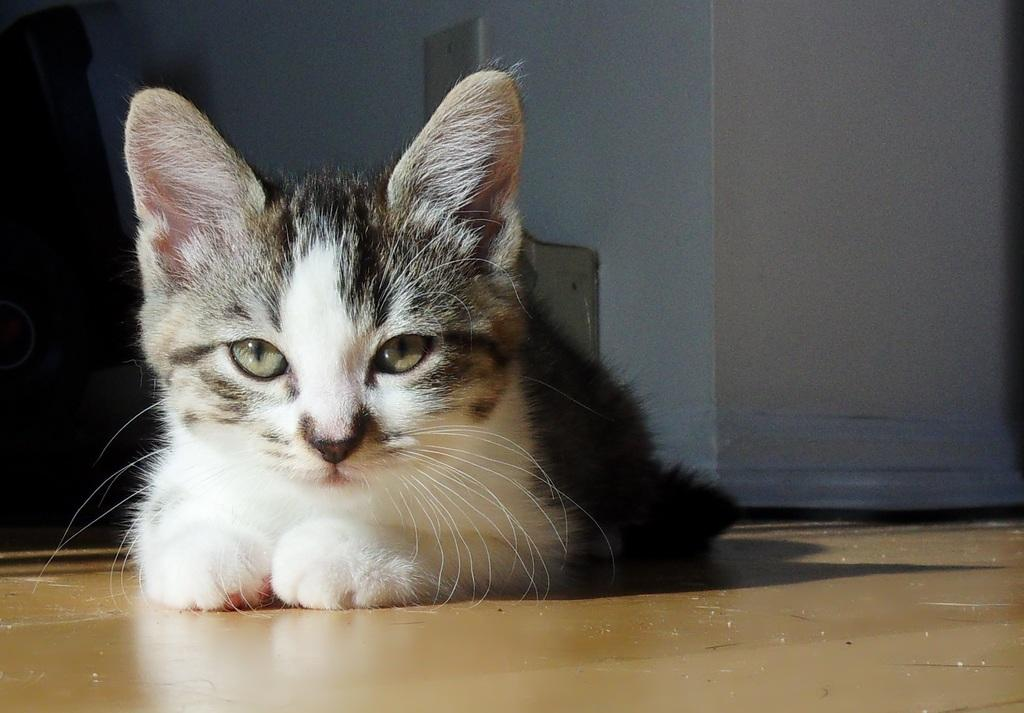Where was the image taken? The image was taken inside a room. What is in the foreground of the image? There is a cat in the foreground of the image. What is the cat doing in the image? The cat is sitting on the floor. What can be seen in the background of the image? There is a wall visible in the background of the image, along with other objects. Can you tell me how many zebras are visible in the image? There are no zebras present in the image. What type of slave is depicted in the image? There is no depiction of a slave in the image; it features a cat sitting on the floor inside a room. 